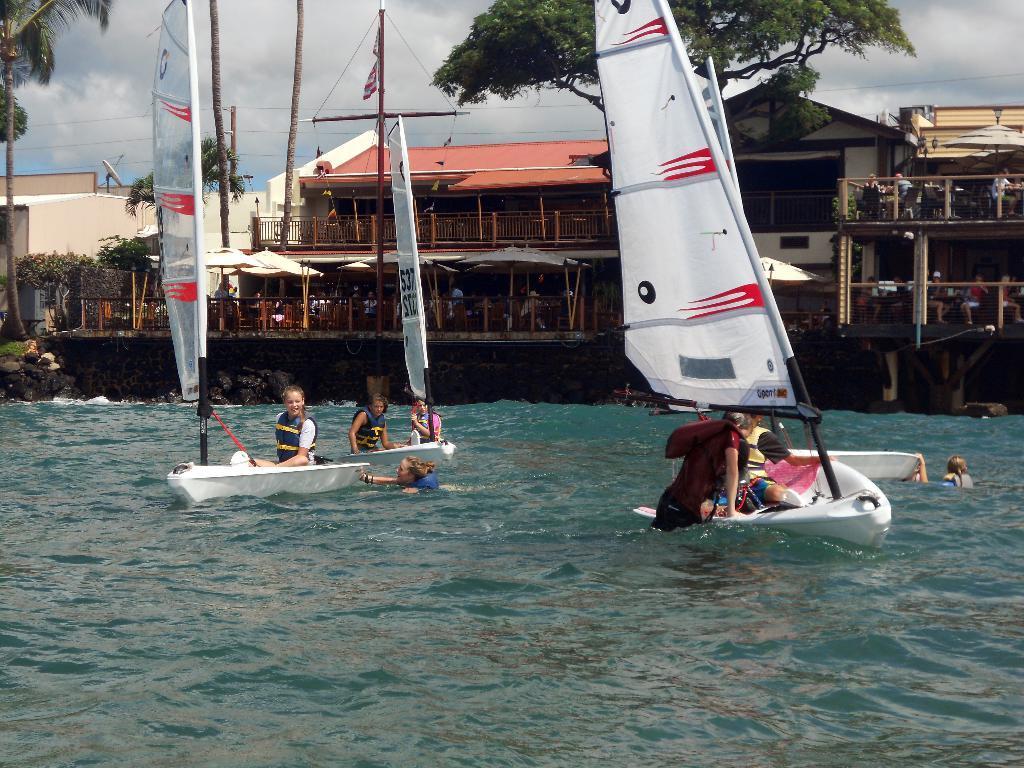In one or two sentences, can you explain what this image depicts? In this picture we can see two small boats in the water. Behind there is a wooden shed house and tree. 